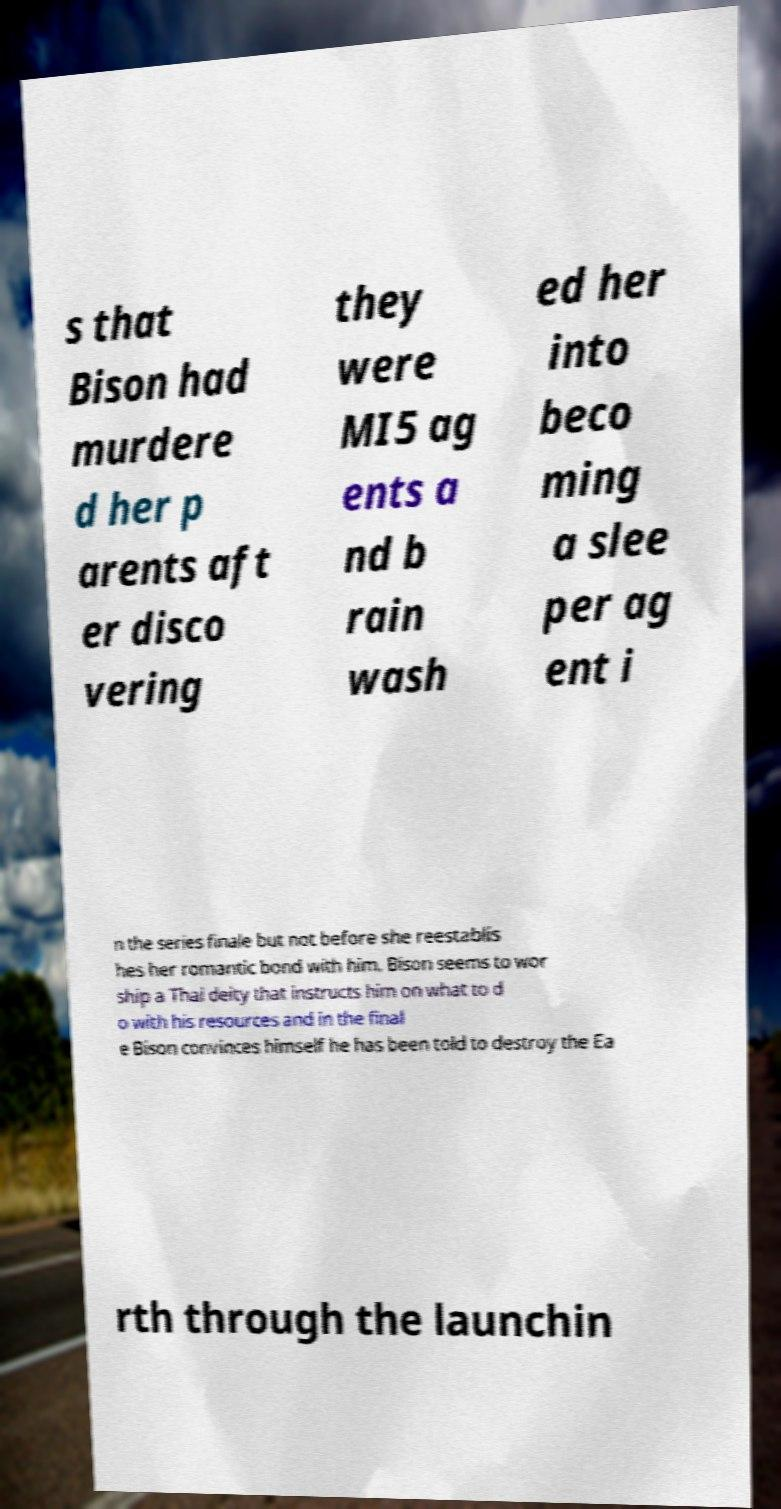Please read and relay the text visible in this image. What does it say? s that Bison had murdere d her p arents aft er disco vering they were MI5 ag ents a nd b rain wash ed her into beco ming a slee per ag ent i n the series finale but not before she reestablis hes her romantic bond with him. Bison seems to wor ship a Thai deity that instructs him on what to d o with his resources and in the final e Bison convinces himself he has been told to destroy the Ea rth through the launchin 